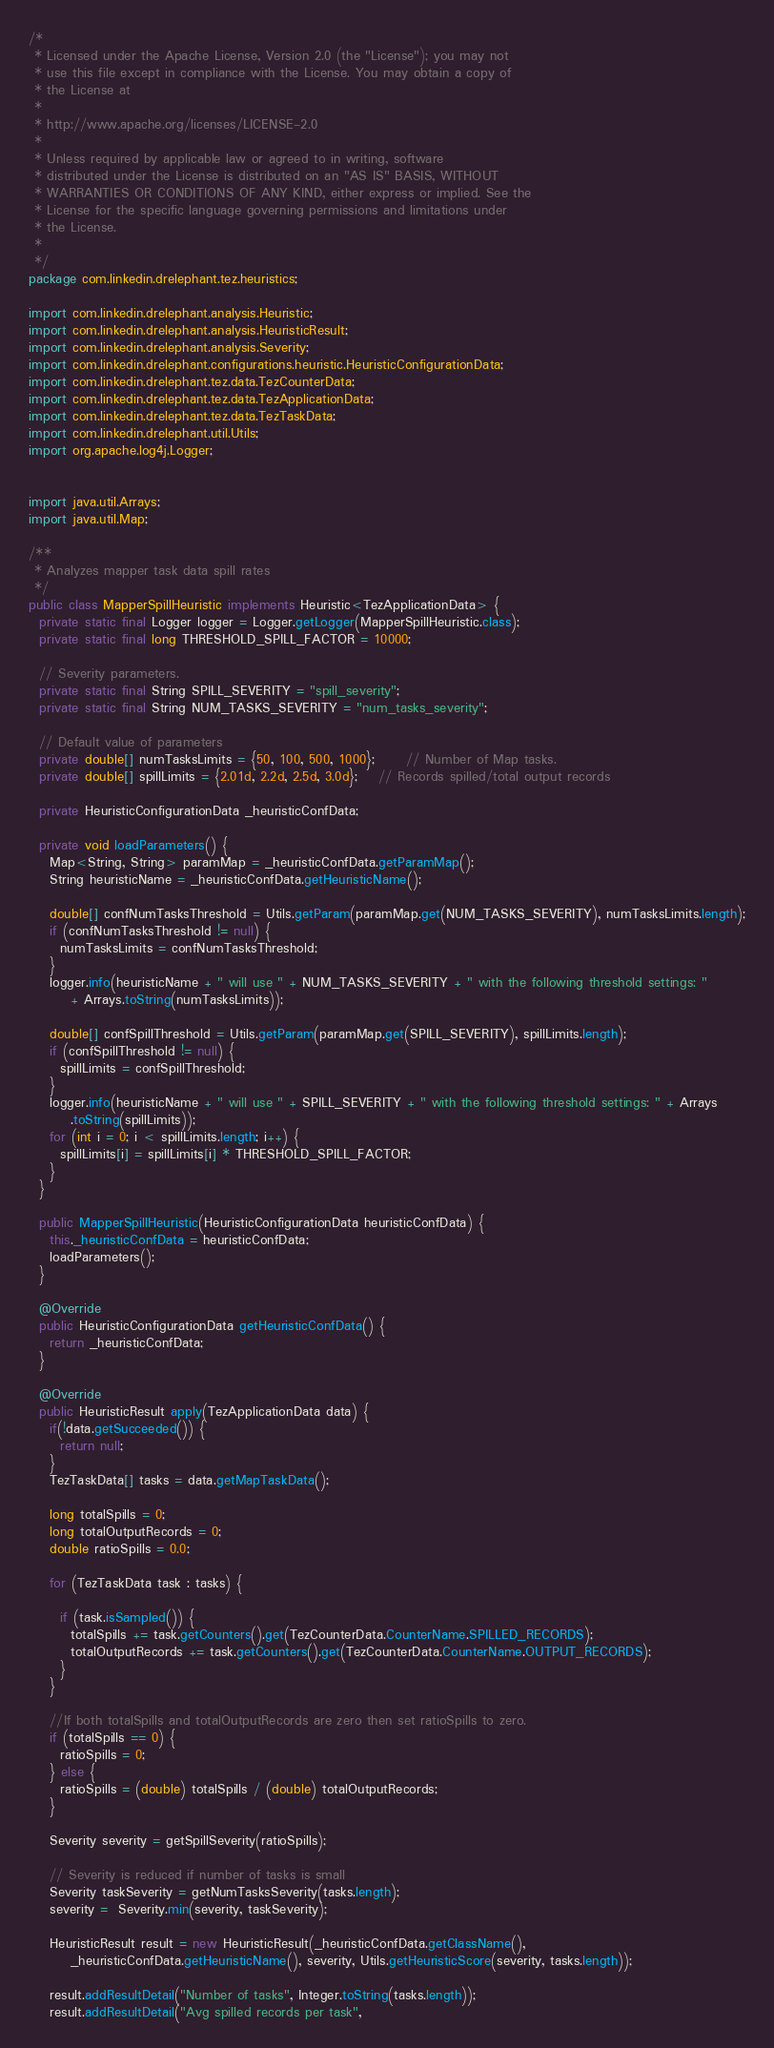Convert code to text. <code><loc_0><loc_0><loc_500><loc_500><_Java_>/*
 * Licensed under the Apache License, Version 2.0 (the "License"); you may not
 * use this file except in compliance with the License. You may obtain a copy of
 * the License at
 *
 * http://www.apache.org/licenses/LICENSE-2.0
 *
 * Unless required by applicable law or agreed to in writing, software
 * distributed under the License is distributed on an "AS IS" BASIS, WITHOUT
 * WARRANTIES OR CONDITIONS OF ANY KIND, either express or implied. See the
 * License for the specific language governing permissions and limitations under
 * the License.
 *
 */
package com.linkedin.drelephant.tez.heuristics;

import com.linkedin.drelephant.analysis.Heuristic;
import com.linkedin.drelephant.analysis.HeuristicResult;
import com.linkedin.drelephant.analysis.Severity;
import com.linkedin.drelephant.configurations.heuristic.HeuristicConfigurationData;
import com.linkedin.drelephant.tez.data.TezCounterData;
import com.linkedin.drelephant.tez.data.TezApplicationData;
import com.linkedin.drelephant.tez.data.TezTaskData;
import com.linkedin.drelephant.util.Utils;
import org.apache.log4j.Logger;


import java.util.Arrays;
import java.util.Map;

/**
 * Analyzes mapper task data spill rates
 */
public class MapperSpillHeuristic implements Heuristic<TezApplicationData> {
  private static final Logger logger = Logger.getLogger(MapperSpillHeuristic.class);
  private static final long THRESHOLD_SPILL_FACTOR = 10000;

  // Severity parameters.
  private static final String SPILL_SEVERITY = "spill_severity";
  private static final String NUM_TASKS_SEVERITY = "num_tasks_severity";

  // Default value of parameters
  private double[] numTasksLimits = {50, 100, 500, 1000};      // Number of Map tasks.
  private double[] spillLimits = {2.01d, 2.2d, 2.5d, 3.0d};    // Records spilled/total output records

  private HeuristicConfigurationData _heuristicConfData;

  private void loadParameters() {
    Map<String, String> paramMap = _heuristicConfData.getParamMap();
    String heuristicName = _heuristicConfData.getHeuristicName();

    double[] confNumTasksThreshold = Utils.getParam(paramMap.get(NUM_TASKS_SEVERITY), numTasksLimits.length);
    if (confNumTasksThreshold != null) {
      numTasksLimits = confNumTasksThreshold;
    }
    logger.info(heuristicName + " will use " + NUM_TASKS_SEVERITY + " with the following threshold settings: "
        + Arrays.toString(numTasksLimits));

    double[] confSpillThreshold = Utils.getParam(paramMap.get(SPILL_SEVERITY), spillLimits.length);
    if (confSpillThreshold != null) {
      spillLimits = confSpillThreshold;
    }
    logger.info(heuristicName + " will use " + SPILL_SEVERITY + " with the following threshold settings: " + Arrays
        .toString(spillLimits));
    for (int i = 0; i < spillLimits.length; i++) {
      spillLimits[i] = spillLimits[i] * THRESHOLD_SPILL_FACTOR;
    }
  }

  public MapperSpillHeuristic(HeuristicConfigurationData heuristicConfData) {
    this._heuristicConfData = heuristicConfData;
    loadParameters();
  }

  @Override
  public HeuristicConfigurationData getHeuristicConfData() {
    return _heuristicConfData;
  }

  @Override
  public HeuristicResult apply(TezApplicationData data) {
    if(!data.getSucceeded()) {
      return null;
    }
    TezTaskData[] tasks = data.getMapTaskData();

    long totalSpills = 0;
    long totalOutputRecords = 0;
    double ratioSpills = 0.0;

    for (TezTaskData task : tasks) {

      if (task.isSampled()) {
        totalSpills += task.getCounters().get(TezCounterData.CounterName.SPILLED_RECORDS);
        totalOutputRecords += task.getCounters().get(TezCounterData.CounterName.OUTPUT_RECORDS);
      }
    }

    //If both totalSpills and totalOutputRecords are zero then set ratioSpills to zero.
    if (totalSpills == 0) {
      ratioSpills = 0;
    } else {
      ratioSpills = (double) totalSpills / (double) totalOutputRecords;
    }

    Severity severity = getSpillSeverity(ratioSpills);

    // Severity is reduced if number of tasks is small
    Severity taskSeverity = getNumTasksSeverity(tasks.length);
    severity =  Severity.min(severity, taskSeverity);

    HeuristicResult result = new HeuristicResult(_heuristicConfData.getClassName(),
        _heuristicConfData.getHeuristicName(), severity, Utils.getHeuristicScore(severity, tasks.length));

    result.addResultDetail("Number of tasks", Integer.toString(tasks.length));
    result.addResultDetail("Avg spilled records per task",</code> 